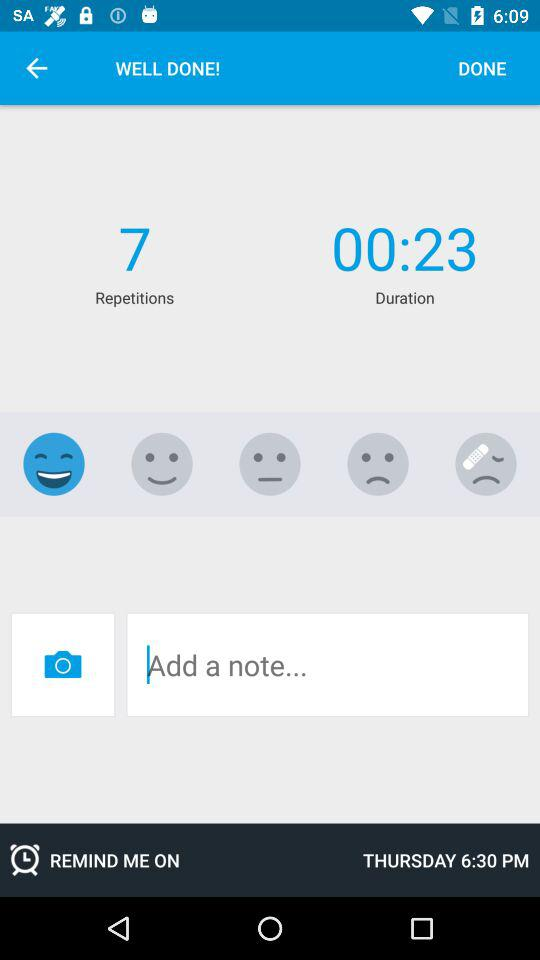What is the time duration? The time duration is 23 seconds. 